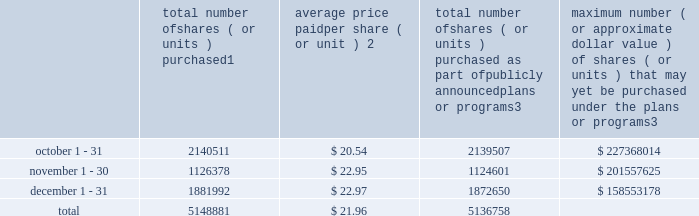Transfer agent and registrar for common stock the transfer agent and registrar for our common stock is : computershare shareowner services llc 480 washington boulevard 29th floor jersey city , new jersey 07310 telephone : ( 877 ) 363-6398 sales of unregistered securities not applicable .
Repurchase of equity securities the table provides information regarding our purchases of our equity securities during the period from october 1 , 2015 to december 31 , 2015 .
Total number of shares ( or units ) purchased 1 average price paid per share ( or unit ) 2 total number of shares ( or units ) purchased as part of publicly announced plans or programs 3 maximum number ( or approximate dollar value ) of shares ( or units ) that may yet be purchased under the plans or programs 3 .
1 included shares of our common stock , par value $ 0.10 per share , withheld under the terms of grants under employee stock-based compensation plans to offset tax withholding obligations that occurred upon vesting and release of restricted shares ( the 201cwithheld shares 201d ) .
We repurchased 1004 withheld shares in october 2015 , 1777 withheld shares in november 2015 and 9342 withheld shares in december 2015 .
2 the average price per share for each of the months in the fiscal quarter and for the three-month period was calculated by dividing the sum of the applicable period of the aggregate value of the tax withholding obligations and the aggregate amount we paid for shares acquired under our stock repurchase program , described in note 5 to the consolidated financial statements , by the sum of the number of withheld shares and the number of shares acquired in our stock repurchase program .
3 in february 2015 , the board authorized a share repurchase program to repurchase from time to time up to $ 300.0 million , excluding fees , of our common stock ( the 201c2015 share repurchase program 201d ) .
On february 12 , 2016 , we announced that our board had approved a new share repurchase program to repurchase from time to time up to $ 300.0 million , excluding fees , of our common stock .
The new authorization is in addition to any amounts remaining for repurchase under the 2015 share repurchase program .
There is no expiration date associated with the share repurchase programs. .
What is the average number of total shares purchased in october and november? 
Computations: ((2140511 + 1126378) / 2)
Answer: 1633444.5. 